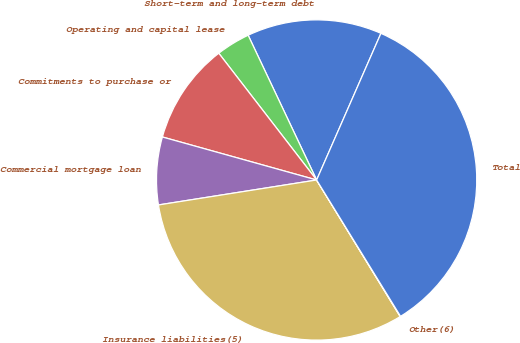Convert chart to OTSL. <chart><loc_0><loc_0><loc_500><loc_500><pie_chart><fcel>Short-term and long-term debt<fcel>Operating and capital lease<fcel>Commitments to purchase or<fcel>Commercial mortgage loan<fcel>Insurance liabilities(5)<fcel>Other(6)<fcel>Total<nl><fcel>13.61%<fcel>3.43%<fcel>10.21%<fcel>6.82%<fcel>31.25%<fcel>0.04%<fcel>34.64%<nl></chart> 